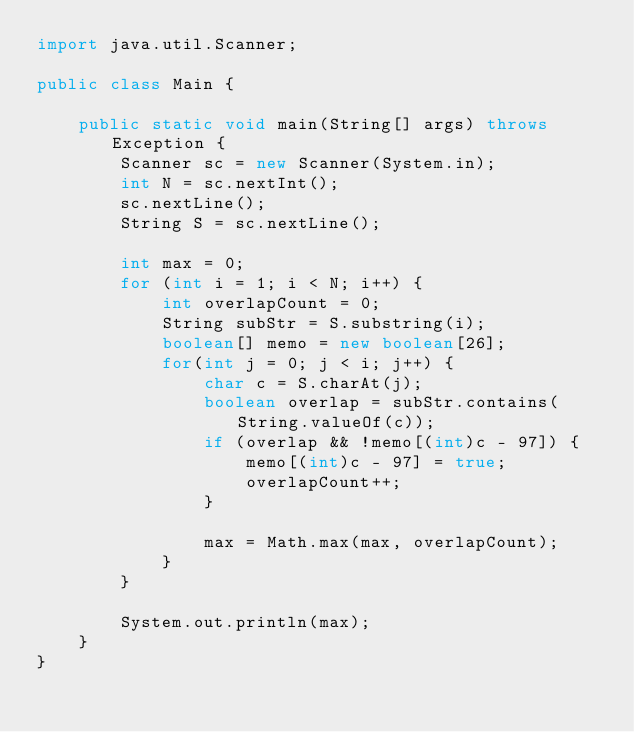Convert code to text. <code><loc_0><loc_0><loc_500><loc_500><_Java_>import java.util.Scanner;

public class Main {
    
    public static void main(String[] args) throws Exception {
        Scanner sc = new Scanner(System.in);
        int N = sc.nextInt();
        sc.nextLine();
        String S = sc.nextLine();
        
        int max = 0;
        for (int i = 1; i < N; i++) {
        	int overlapCount = 0;
        	String subStr = S.substring(i);
        	boolean[] memo = new boolean[26];
        	for(int j = 0; j < i; j++) {
        		char c = S.charAt(j);
        		boolean overlap = subStr.contains(String.valueOf(c));
        		if (overlap && !memo[(int)c - 97]) {
        			memo[(int)c - 97] = true;
        			overlapCount++;
        		}
        		
        		max = Math.max(max, overlapCount);
        	}
        }
        
        System.out.println(max);
    }
}
</code> 